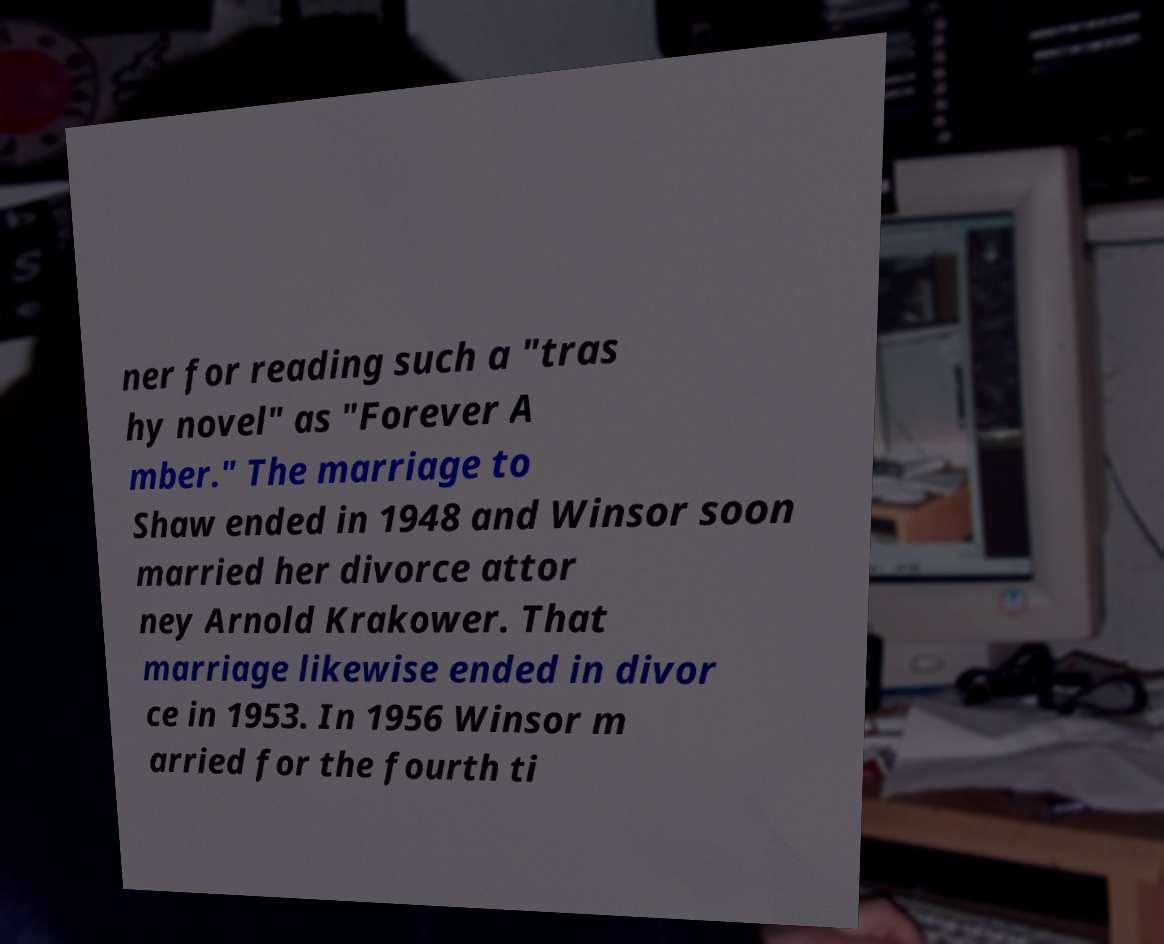Can you accurately transcribe the text from the provided image for me? ner for reading such a "tras hy novel" as "Forever A mber." The marriage to Shaw ended in 1948 and Winsor soon married her divorce attor ney Arnold Krakower. That marriage likewise ended in divor ce in 1953. In 1956 Winsor m arried for the fourth ti 